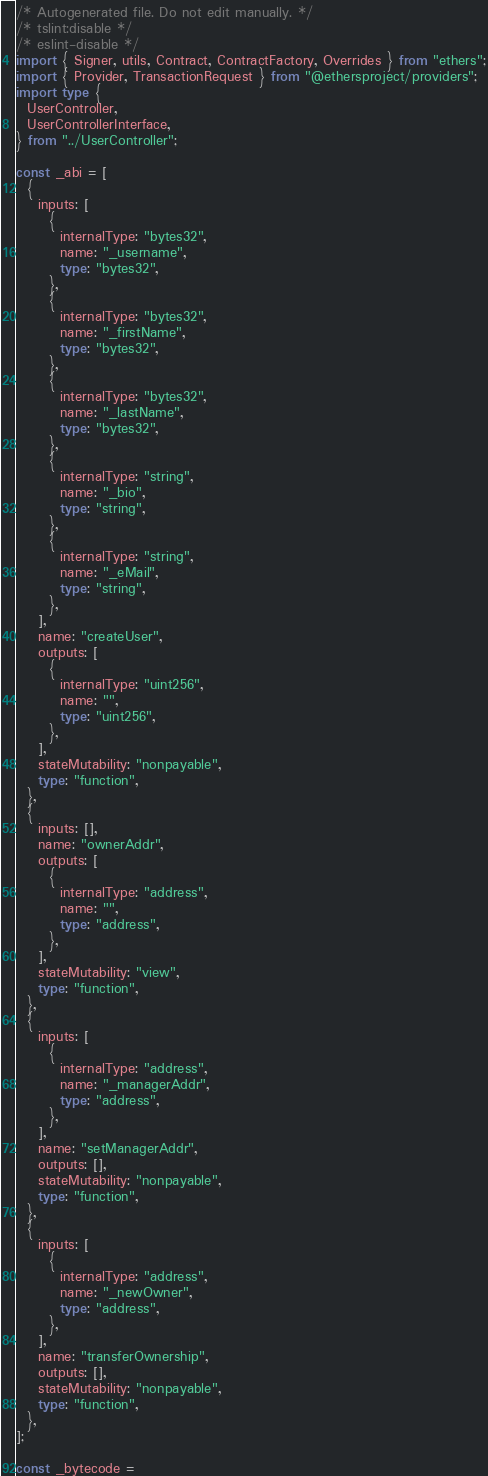<code> <loc_0><loc_0><loc_500><loc_500><_TypeScript_>/* Autogenerated file. Do not edit manually. */
/* tslint:disable */
/* eslint-disable */
import { Signer, utils, Contract, ContractFactory, Overrides } from "ethers";
import { Provider, TransactionRequest } from "@ethersproject/providers";
import type {
  UserController,
  UserControllerInterface,
} from "../UserController";

const _abi = [
  {
    inputs: [
      {
        internalType: "bytes32",
        name: "_username",
        type: "bytes32",
      },
      {
        internalType: "bytes32",
        name: "_firstName",
        type: "bytes32",
      },
      {
        internalType: "bytes32",
        name: "_lastName",
        type: "bytes32",
      },
      {
        internalType: "string",
        name: "_bio",
        type: "string",
      },
      {
        internalType: "string",
        name: "_eMail",
        type: "string",
      },
    ],
    name: "createUser",
    outputs: [
      {
        internalType: "uint256",
        name: "",
        type: "uint256",
      },
    ],
    stateMutability: "nonpayable",
    type: "function",
  },
  {
    inputs: [],
    name: "ownerAddr",
    outputs: [
      {
        internalType: "address",
        name: "",
        type: "address",
      },
    ],
    stateMutability: "view",
    type: "function",
  },
  {
    inputs: [
      {
        internalType: "address",
        name: "_managerAddr",
        type: "address",
      },
    ],
    name: "setManagerAddr",
    outputs: [],
    stateMutability: "nonpayable",
    type: "function",
  },
  {
    inputs: [
      {
        internalType: "address",
        name: "_newOwner",
        type: "address",
      },
    ],
    name: "transferOwnership",
    outputs: [],
    stateMutability: "nonpayable",
    type: "function",
  },
];

const _bytecode =</code> 